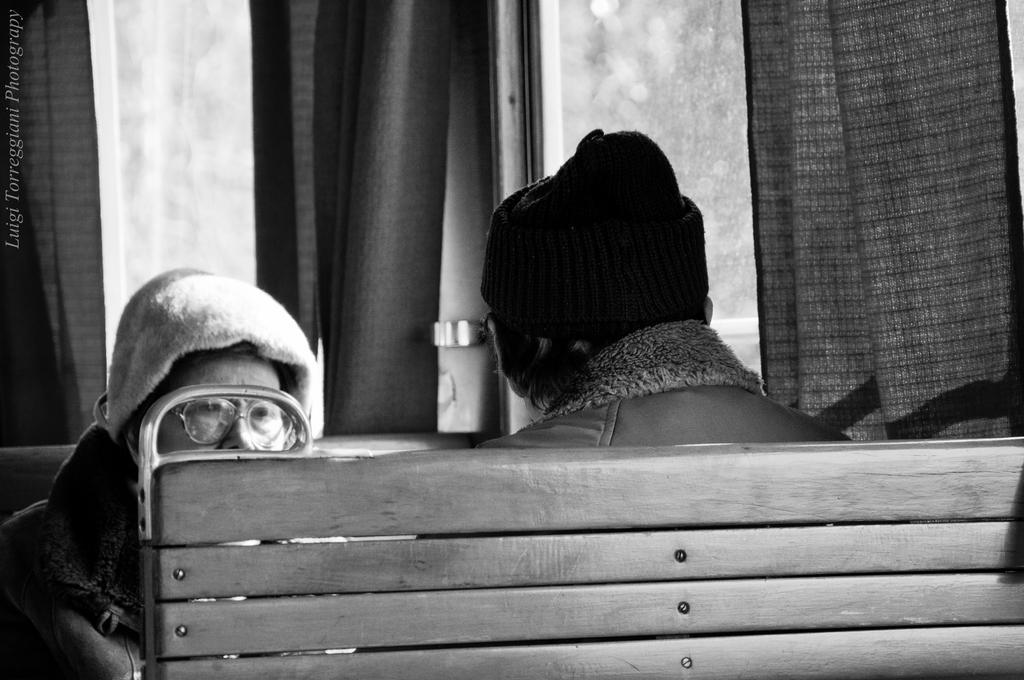Could you give a brief overview of what you see in this image? In this picture I can see two persons are sitting on the benches, side there are some glass windows with curtains. 